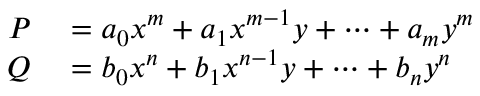Convert formula to latex. <formula><loc_0><loc_0><loc_500><loc_500>\begin{array} { r l } { P } & = a _ { 0 } x ^ { m } + a _ { 1 } x ^ { m - 1 } y + \cdots + a _ { m } y ^ { m } } \\ { Q } & = b _ { 0 } x ^ { n } + b _ { 1 } x ^ { n - 1 } y + \cdots + b _ { n } y ^ { n } } \end{array}</formula> 